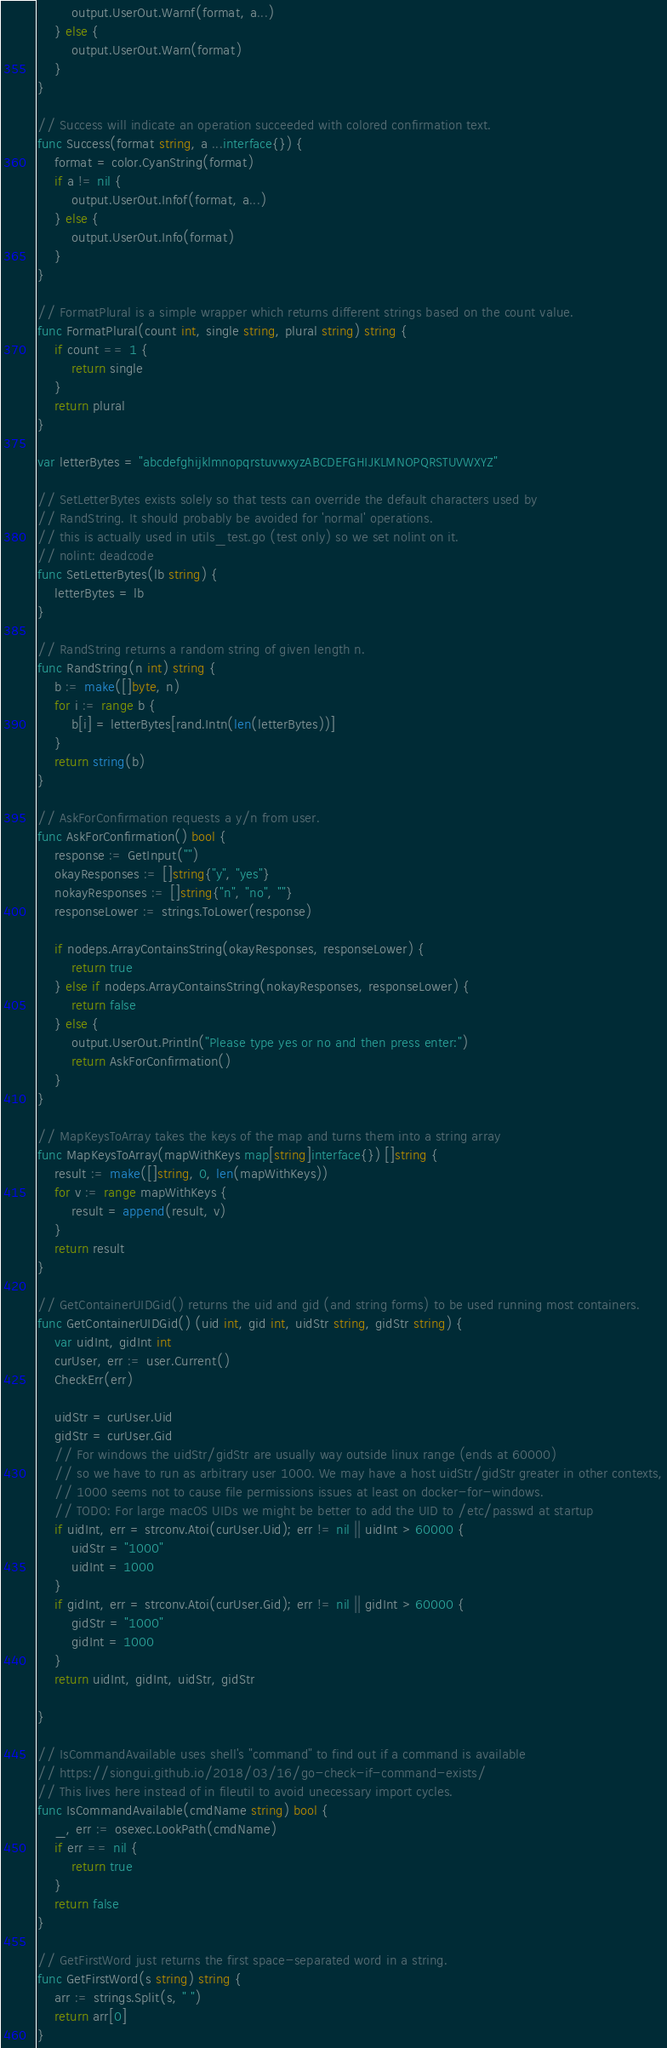Convert code to text. <code><loc_0><loc_0><loc_500><loc_500><_Go_>		output.UserOut.Warnf(format, a...)
	} else {
		output.UserOut.Warn(format)
	}
}

// Success will indicate an operation succeeded with colored confirmation text.
func Success(format string, a ...interface{}) {
	format = color.CyanString(format)
	if a != nil {
		output.UserOut.Infof(format, a...)
	} else {
		output.UserOut.Info(format)
	}
}

// FormatPlural is a simple wrapper which returns different strings based on the count value.
func FormatPlural(count int, single string, plural string) string {
	if count == 1 {
		return single
	}
	return plural
}

var letterBytes = "abcdefghijklmnopqrstuvwxyzABCDEFGHIJKLMNOPQRSTUVWXYZ"

// SetLetterBytes exists solely so that tests can override the default characters used by
// RandString. It should probably be avoided for 'normal' operations.
// this is actually used in utils_test.go (test only) so we set nolint on it.
// nolint: deadcode
func SetLetterBytes(lb string) {
	letterBytes = lb
}

// RandString returns a random string of given length n.
func RandString(n int) string {
	b := make([]byte, n)
	for i := range b {
		b[i] = letterBytes[rand.Intn(len(letterBytes))]
	}
	return string(b)
}

// AskForConfirmation requests a y/n from user.
func AskForConfirmation() bool {
	response := GetInput("")
	okayResponses := []string{"y", "yes"}
	nokayResponses := []string{"n", "no", ""}
	responseLower := strings.ToLower(response)

	if nodeps.ArrayContainsString(okayResponses, responseLower) {
		return true
	} else if nodeps.ArrayContainsString(nokayResponses, responseLower) {
		return false
	} else {
		output.UserOut.Println("Please type yes or no and then press enter:")
		return AskForConfirmation()
	}
}

// MapKeysToArray takes the keys of the map and turns them into a string array
func MapKeysToArray(mapWithKeys map[string]interface{}) []string {
	result := make([]string, 0, len(mapWithKeys))
	for v := range mapWithKeys {
		result = append(result, v)
	}
	return result
}

// GetContainerUIDGid() returns the uid and gid (and string forms) to be used running most containers.
func GetContainerUIDGid() (uid int, gid int, uidStr string, gidStr string) {
	var uidInt, gidInt int
	curUser, err := user.Current()
	CheckErr(err)

	uidStr = curUser.Uid
	gidStr = curUser.Gid
	// For windows the uidStr/gidStr are usually way outside linux range (ends at 60000)
	// so we have to run as arbitrary user 1000. We may have a host uidStr/gidStr greater in other contexts,
	// 1000 seems not to cause file permissions issues at least on docker-for-windows.
	// TODO: For large macOS UIDs we might be better to add the UID to /etc/passwd at startup
	if uidInt, err = strconv.Atoi(curUser.Uid); err != nil || uidInt > 60000 {
		uidStr = "1000"
		uidInt = 1000
	}
	if gidInt, err = strconv.Atoi(curUser.Gid); err != nil || gidInt > 60000 {
		gidStr = "1000"
		gidInt = 1000
	}
	return uidInt, gidInt, uidStr, gidStr

}

// IsCommandAvailable uses shell's "command" to find out if a command is available
// https://siongui.github.io/2018/03/16/go-check-if-command-exists/
// This lives here instead of in fileutil to avoid unecessary import cycles.
func IsCommandAvailable(cmdName string) bool {
	_, err := osexec.LookPath(cmdName)
	if err == nil {
		return true
	}
	return false
}

// GetFirstWord just returns the first space-separated word in a string.
func GetFirstWord(s string) string {
	arr := strings.Split(s, " ")
	return arr[0]
}
</code> 